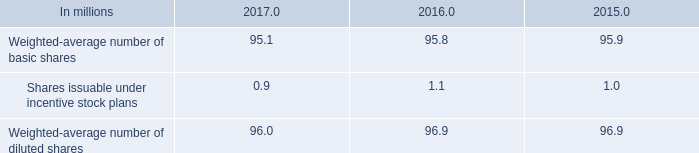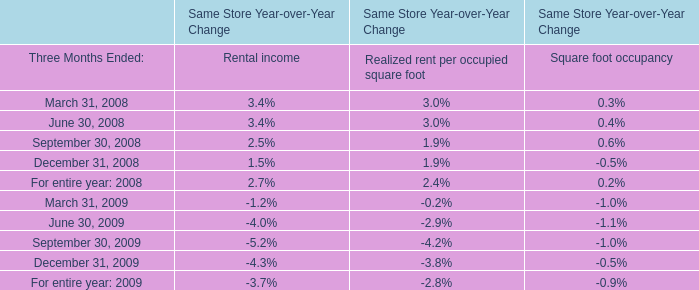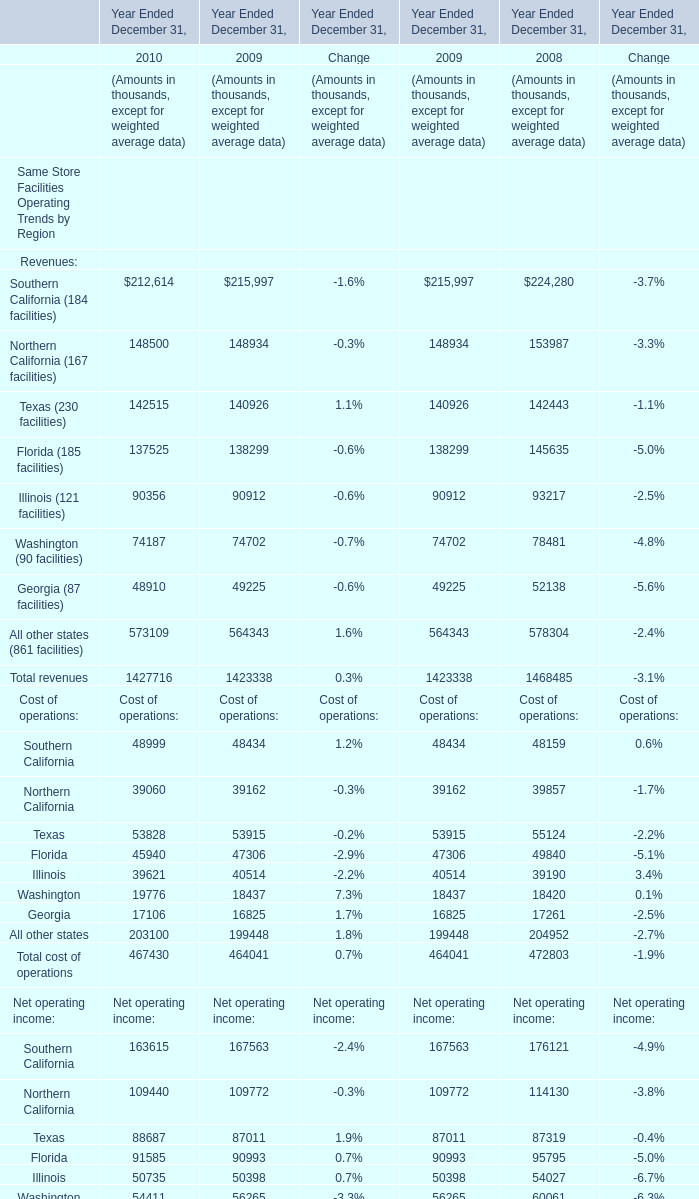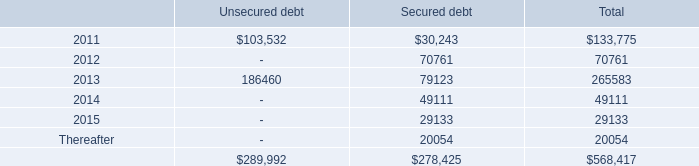What is the average value of All other states (861 facilities) in 2010, 2009 and 2008? (in thousand) 
Computations: (((573109 + 564343) + 578304) / 3)
Answer: 571918.66667. 